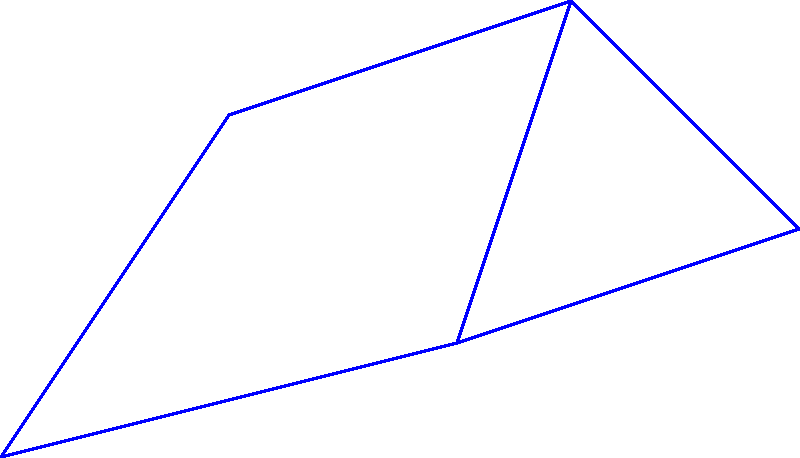In a virtual retirement community, five retirees (R1 to R5) are connected through a social network as shown in the graph. The numbers on the edges represent the strength of connection between two retirees (lower numbers indicate stronger connections). What is the shortest path from R1 to R5, and what is the total strength of this path? To find the shortest path from R1 to R5, we need to consider all possible paths and their total strengths:

1. R1 → R2 → R4 → R5: 5 + 3 + 4 = 12
2. R1 → R3 → R4 → R5: 4 + 2 + 4 = 10
3. R1 → R3 → R5: 4 + 3 = 7

Step 1: Identify all possible paths from R1 to R5.
Step 2: Calculate the total strength for each path by summing the edge weights.
Step 3: Compare the total strengths:
   Path 1: 12
   Path 2: 10
   Path 3: 7
Step 4: Select the path with the lowest total strength, which is Path 3 (R1 → R3 → R5) with a total strength of 7.

Therefore, the shortest path from R1 to R5 is R1 → R3 → R5, and the total strength of this path is 7.
Answer: R1 → R3 → R5; 7 